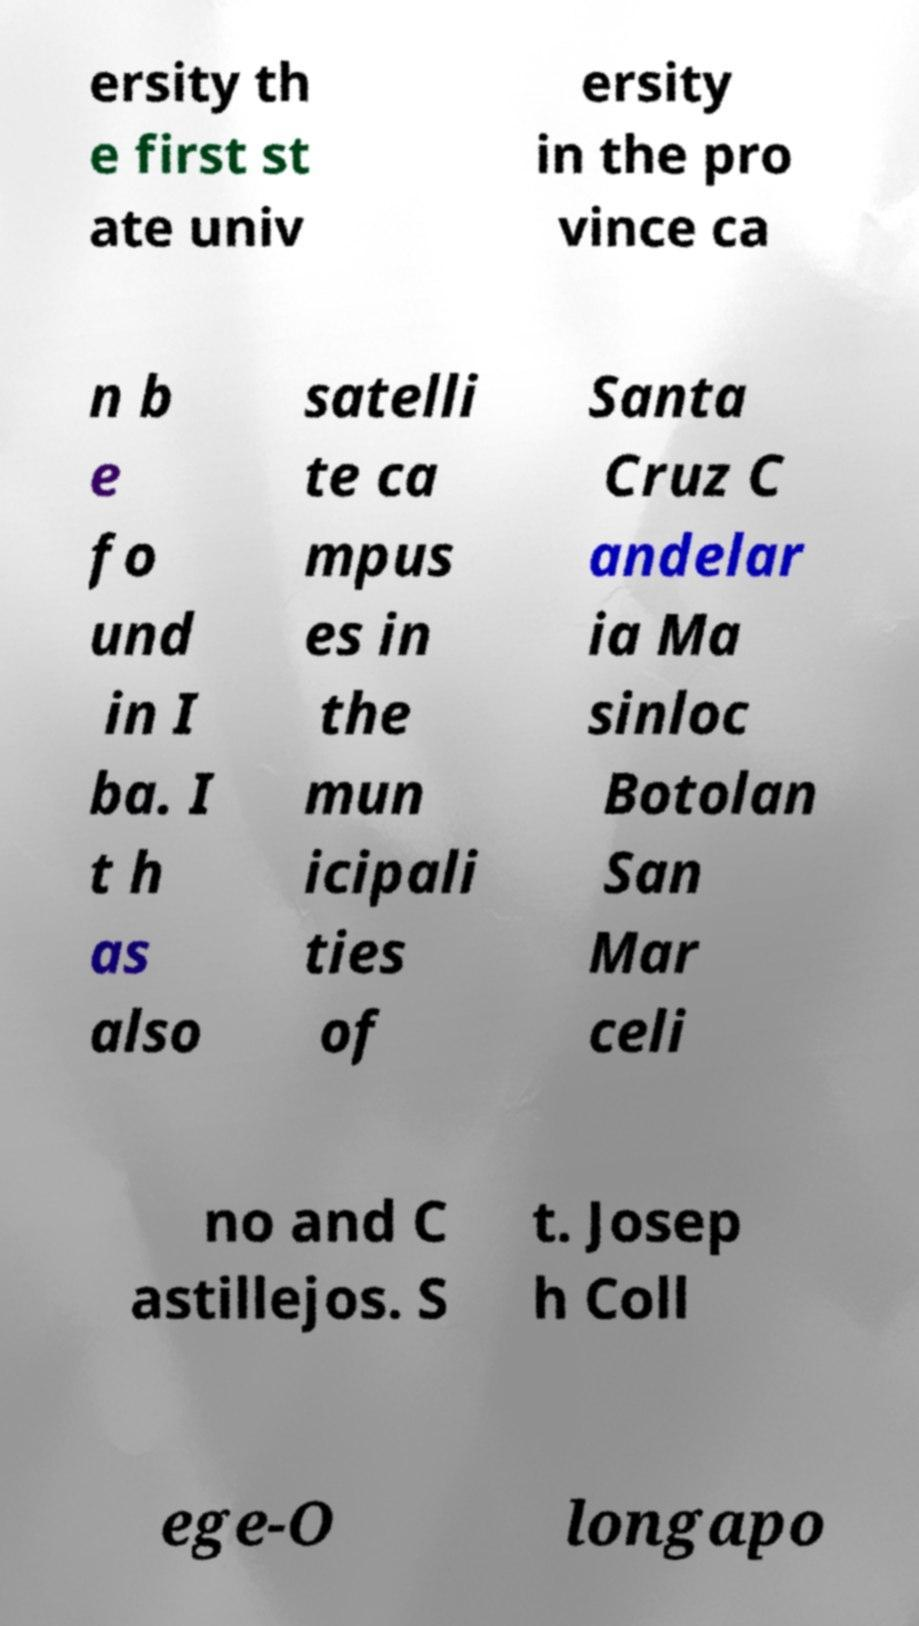Please read and relay the text visible in this image. What does it say? ersity th e first st ate univ ersity in the pro vince ca n b e fo und in I ba. I t h as also satelli te ca mpus es in the mun icipali ties of Santa Cruz C andelar ia Ma sinloc Botolan San Mar celi no and C astillejos. S t. Josep h Coll ege-O longapo 